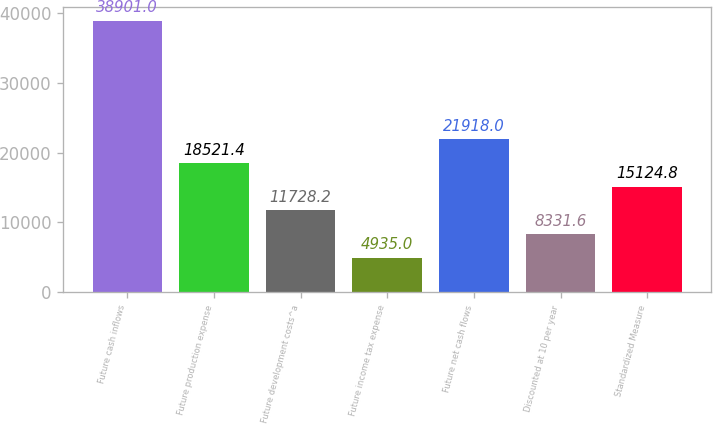Convert chart to OTSL. <chart><loc_0><loc_0><loc_500><loc_500><bar_chart><fcel>Future cash inflows<fcel>Future production expense<fcel>Future development costs^a<fcel>Future income tax expense<fcel>Future net cash flows<fcel>Discounted at 10 per year<fcel>Standardized Measure<nl><fcel>38901<fcel>18521.4<fcel>11728.2<fcel>4935<fcel>21918<fcel>8331.6<fcel>15124.8<nl></chart> 